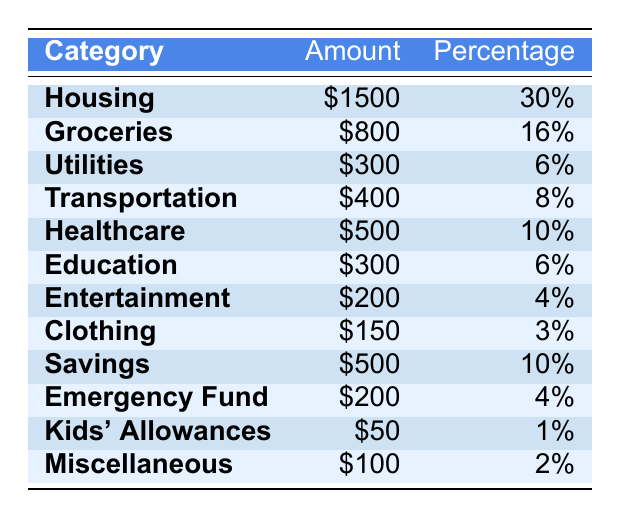What is the total amount allocated for Housing? The table shows that the amount allocated for Housing is $1500.
Answer: $1500 What percentage of the total budget is spent on Groceries? The table indicates that 16% of the total budget is allocated for Groceries.
Answer: 16% What is the combined amount for Healthcare and Education? Healthcare is $500 and Education is $300. Adding these amounts gives $500 + $300 = $800.
Answer: $800 Is the amount spent on Transportation greater than that spent on Utilities? The amount for Transportation is $400 and for Utilities is $300. Since $400 is greater than $300, the statement is true.
Answer: Yes What is the total budget for all categories? To find the total budget, add all the amounts: $1500 + $800 + $300 + $400 + $500 + $300 + $200 + $150 + $500 + $200 + $50 + $100 = $4000.
Answer: $4000 What percentage is allocated for Savings compared to Transportation? Savings is 10% and Transportation is 8%. Since 10% is greater than 8%, the percentage for Savings is higher.
Answer: Higher Calculate the total amount allocated for both Emergency Fund and Kids' Allowances. Emergency Fund is $200 and Kids' Allowances is $50. The combined amount is $200 + $50 = $250.
Answer: $250 What is the portion of the budget spent on Clothing relative to the total budget? The Clothing budget is $150, and since the total budget is $4000, the portion for Clothing is $150 / $4000 = 3.75%. This rounds to approximately 4%.
Answer: 4% What is the difference in amount between the highest and lowest budget categories? The highest category is Housing at $1500, and the lowest is Kids' Allowances at $50. The difference is $1500 - $50 = $1450.
Answer: $1450 Is the percentage of the budget spent on Entertainment less than 5%? The percentage for Entertainment is 4%, which is less than 5%. So the statement is true.
Answer: Yes What is the average spending in the budget for a category? There are 12 categories; sum all the amounts ($4000) and divide by 12: $4000 / 12 = $333.33.
Answer: $333.33 